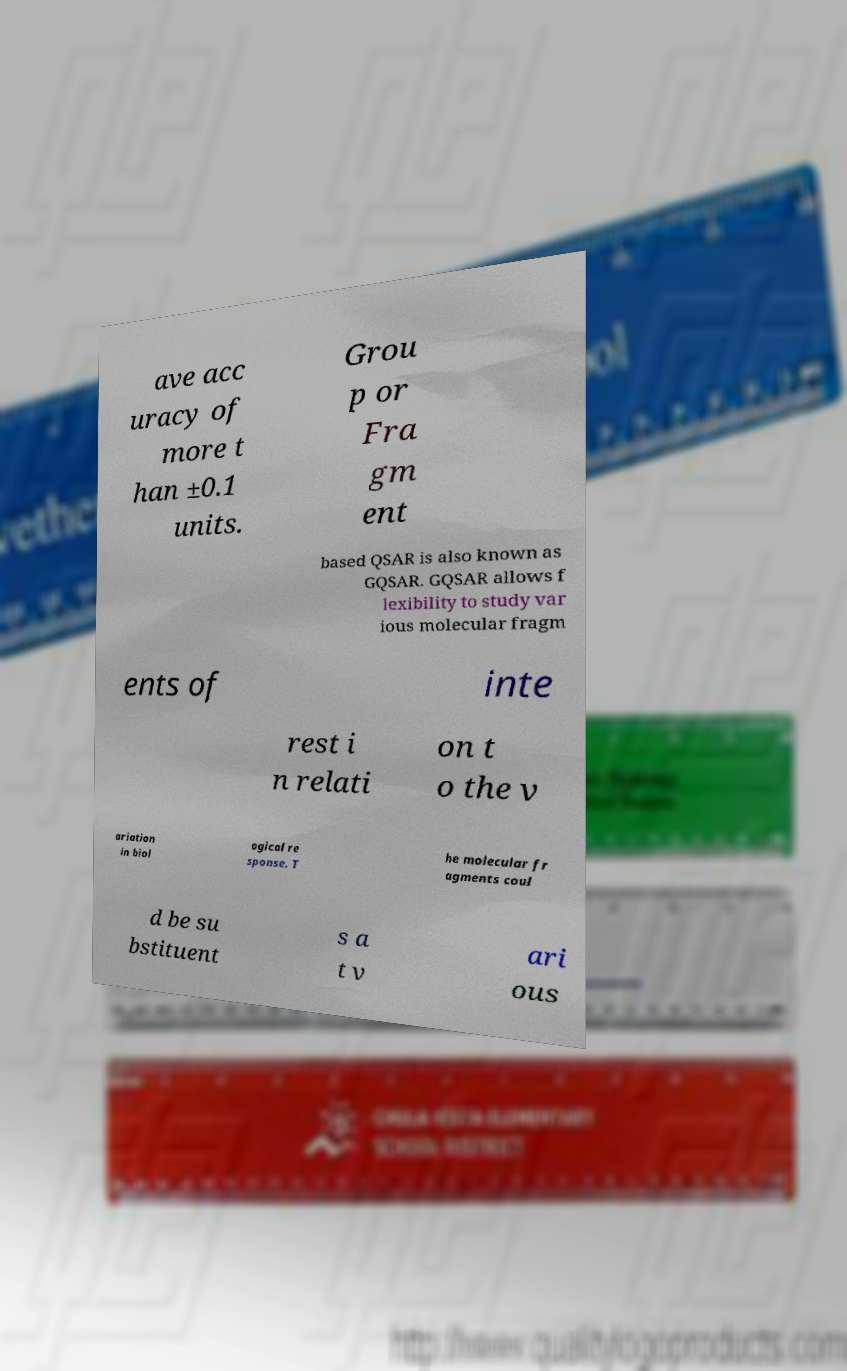Could you assist in decoding the text presented in this image and type it out clearly? ave acc uracy of more t han ±0.1 units. Grou p or Fra gm ent based QSAR is also known as GQSAR. GQSAR allows f lexibility to study var ious molecular fragm ents of inte rest i n relati on t o the v ariation in biol ogical re sponse. T he molecular fr agments coul d be su bstituent s a t v ari ous 